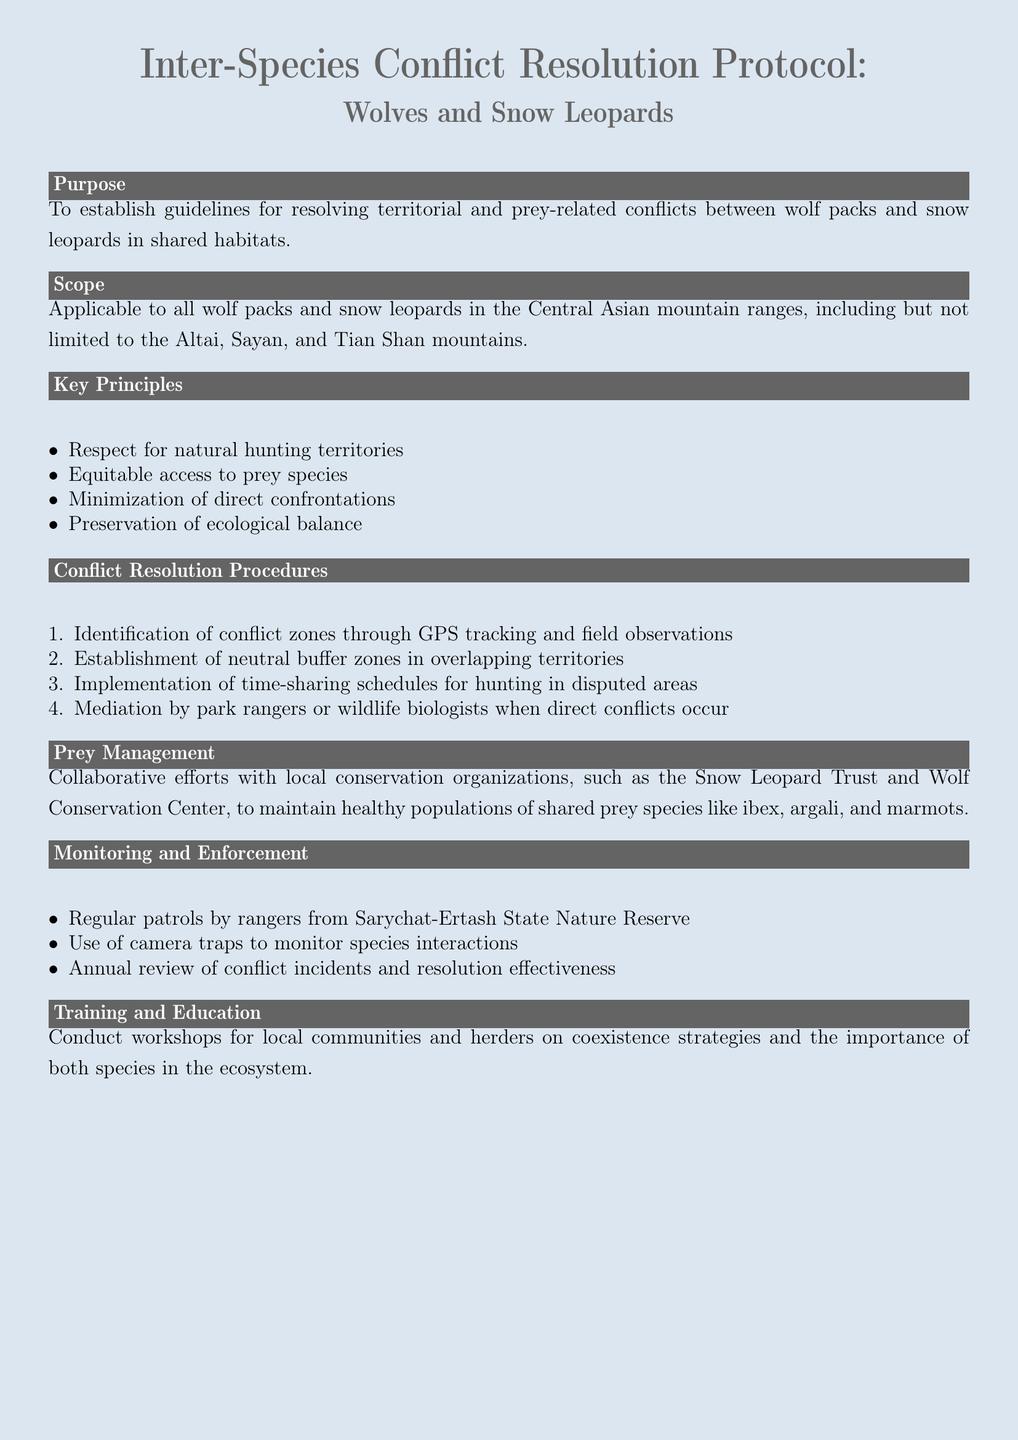What is the purpose of the protocol? The purpose is to establish guidelines for resolving territorial and prey-related conflicts between wolf packs and snow leopards in shared habitats.
Answer: Establish guidelines for resolving conflicts What species are included in the scope? The scope mentions all wolf packs and snow leopards in the Central Asian mountain ranges.
Answer: Wolf packs and snow leopards How many key principles are listed in the document? There are four key principles listed under the Key Principles section.
Answer: Four What is the first step in the conflict resolution procedures? The first step is the identification of conflict zones through GPS tracking and field observations.
Answer: Identification of conflict zones Which organizations are mentioned for prey management? The document mentions the Snow Leopard Trust and Wolf Conservation Center for collaborative efforts.
Answer: Snow Leopard Trust and Wolf Conservation Center What is the purpose of regular patrols mentioned in the monitoring section? The purpose is to monitor species interactions and ensure enforcement of the protocol.
Answer: Monitor species interactions How often is the review of conflict incidents planned? The document states that there will be an annual review of conflict incidents and resolution effectiveness.
Answer: Annual review What type of workshops are conducted according to the training section? Workshops are conducted for local communities and herders on coexistence strategies.
Answer: Coexistence strategies 